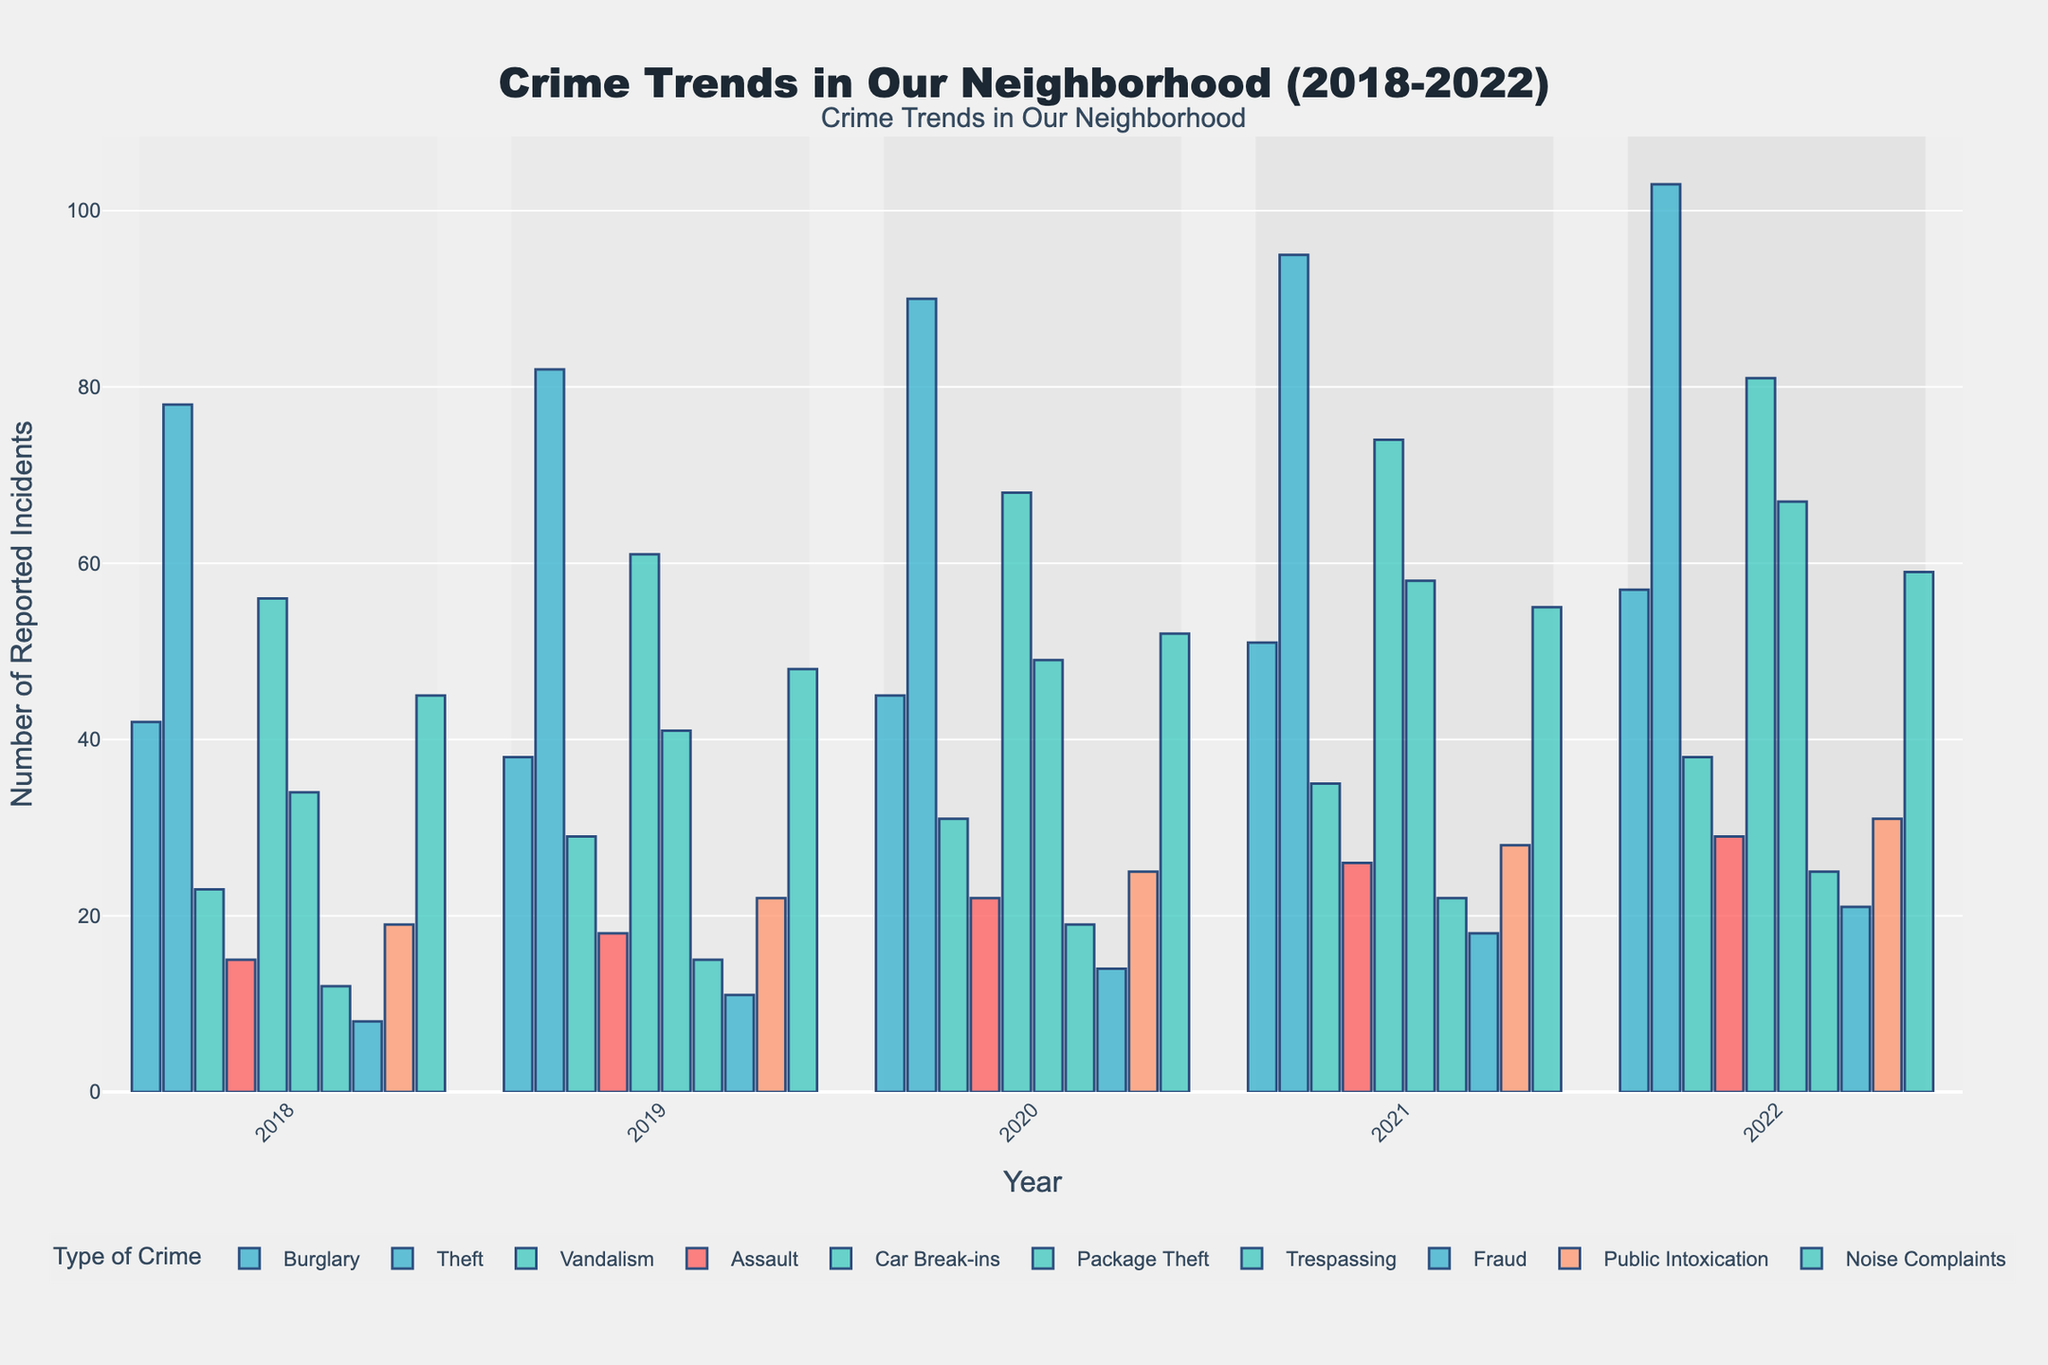Which type of crime showed the highest increase over the 5 years? To find this, look at the starting and ending values for each crime type from 2018 to 2022. Subtract the 2018 value from the 2022 value to find the increase for each crime type. The crime with the highest difference is the one with the biggest increase.
Answer: Package Theft Which crime had the highest number of reported incidents in 2022? Check the height of the bars for each crime type in the year 2022 column and find the tallest bar to identify which crime had the highest number of reported incidents.
Answer: Theft How does the number of Burglary reports in 2022 compare to 2018? Refer to the bar heights for Burglary in 2018 and 2022. Compare the values to see if the number has increased or decreased.
Answer: Increased Which two crimes had a reported number of incidents closest to each other in 2021? Look at the heights of the bars for each crime type in 2021 and find the two bars that have similar heights.
Answer: Trespassing and Fraud What's the average number of reported incidents for Assault over the 5 years? Sum the reported incidents for Assault from 2018 to 2022 and divide by 5. (15+18+22+26+29) = 110. 110/5 = 22.
Answer: 22 In which year did Vandalism see the biggest jump in reported incidents compared to the previous year? For each year from 2019 onwards, subtract the previous year's reported incidents for Vandalism and identify the year with the greatest increase.
Answer: 2020 How many types of crimes had more than 50 reported incidents in 2022? Check the heights of the bars for each crime type in 2022 and count how many surpass the 50 mark.
Answer: 5 types Which type of crime saw a consistent increase in reports every year? Look for crime types where the height of the bar increases from left to right (2018-2022) for all years.
Answer: Package Theft Compare the 2022 reports of Car Break-ins and Public Intoxication. Which had more, and by how much? Refer to the bar heights for Car Break-ins and Public Intoxication in 2022. Subtract the smaller value from the larger one. Car Break-ins: 81; Public Intoxication: 31; 81 - 31 = 50.
Answer: Car Break-ins by 50 What is the combined total of reported incidents of Noise Complaints and Fraud in 2020? Add the reported incidents for Noise Complaints and Fraud in the year 2020. Noise Complaints: 52; Fraud: 14; 52 + 14 = 66.
Answer: 66 